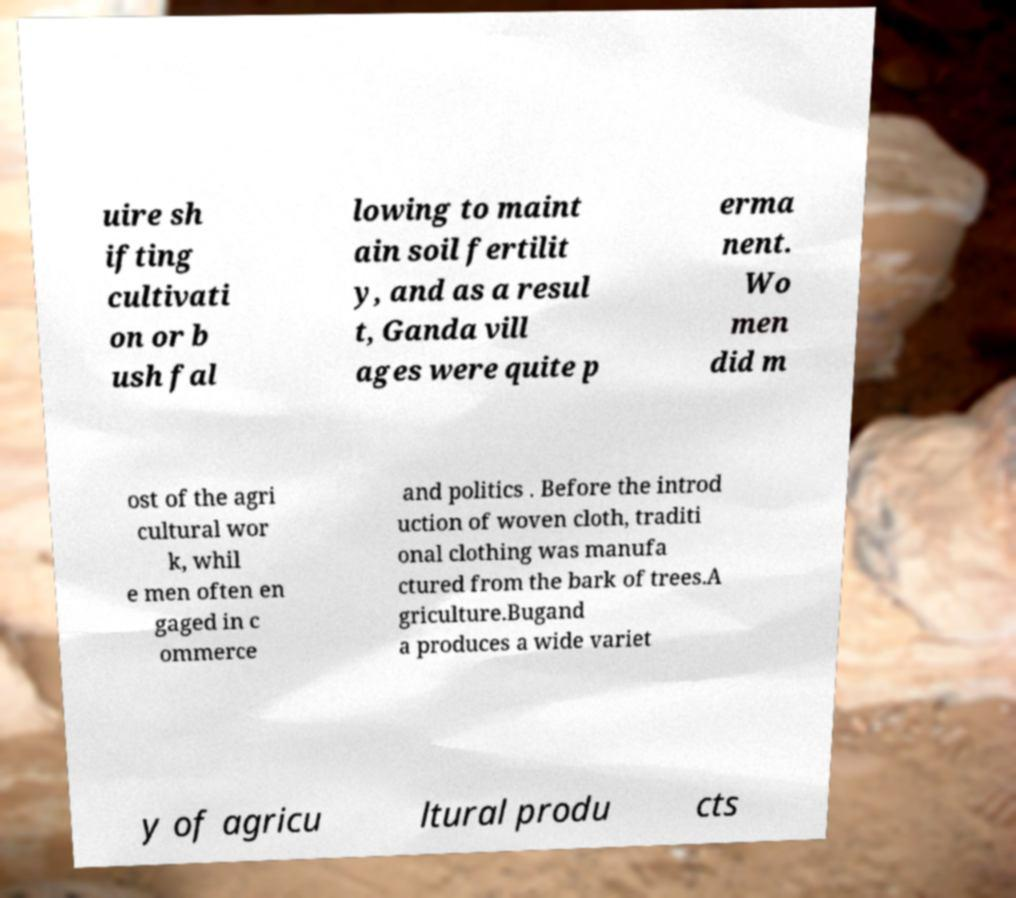Could you extract and type out the text from this image? uire sh ifting cultivati on or b ush fal lowing to maint ain soil fertilit y, and as a resul t, Ganda vill ages were quite p erma nent. Wo men did m ost of the agri cultural wor k, whil e men often en gaged in c ommerce and politics . Before the introd uction of woven cloth, traditi onal clothing was manufa ctured from the bark of trees.A griculture.Bugand a produces a wide variet y of agricu ltural produ cts 